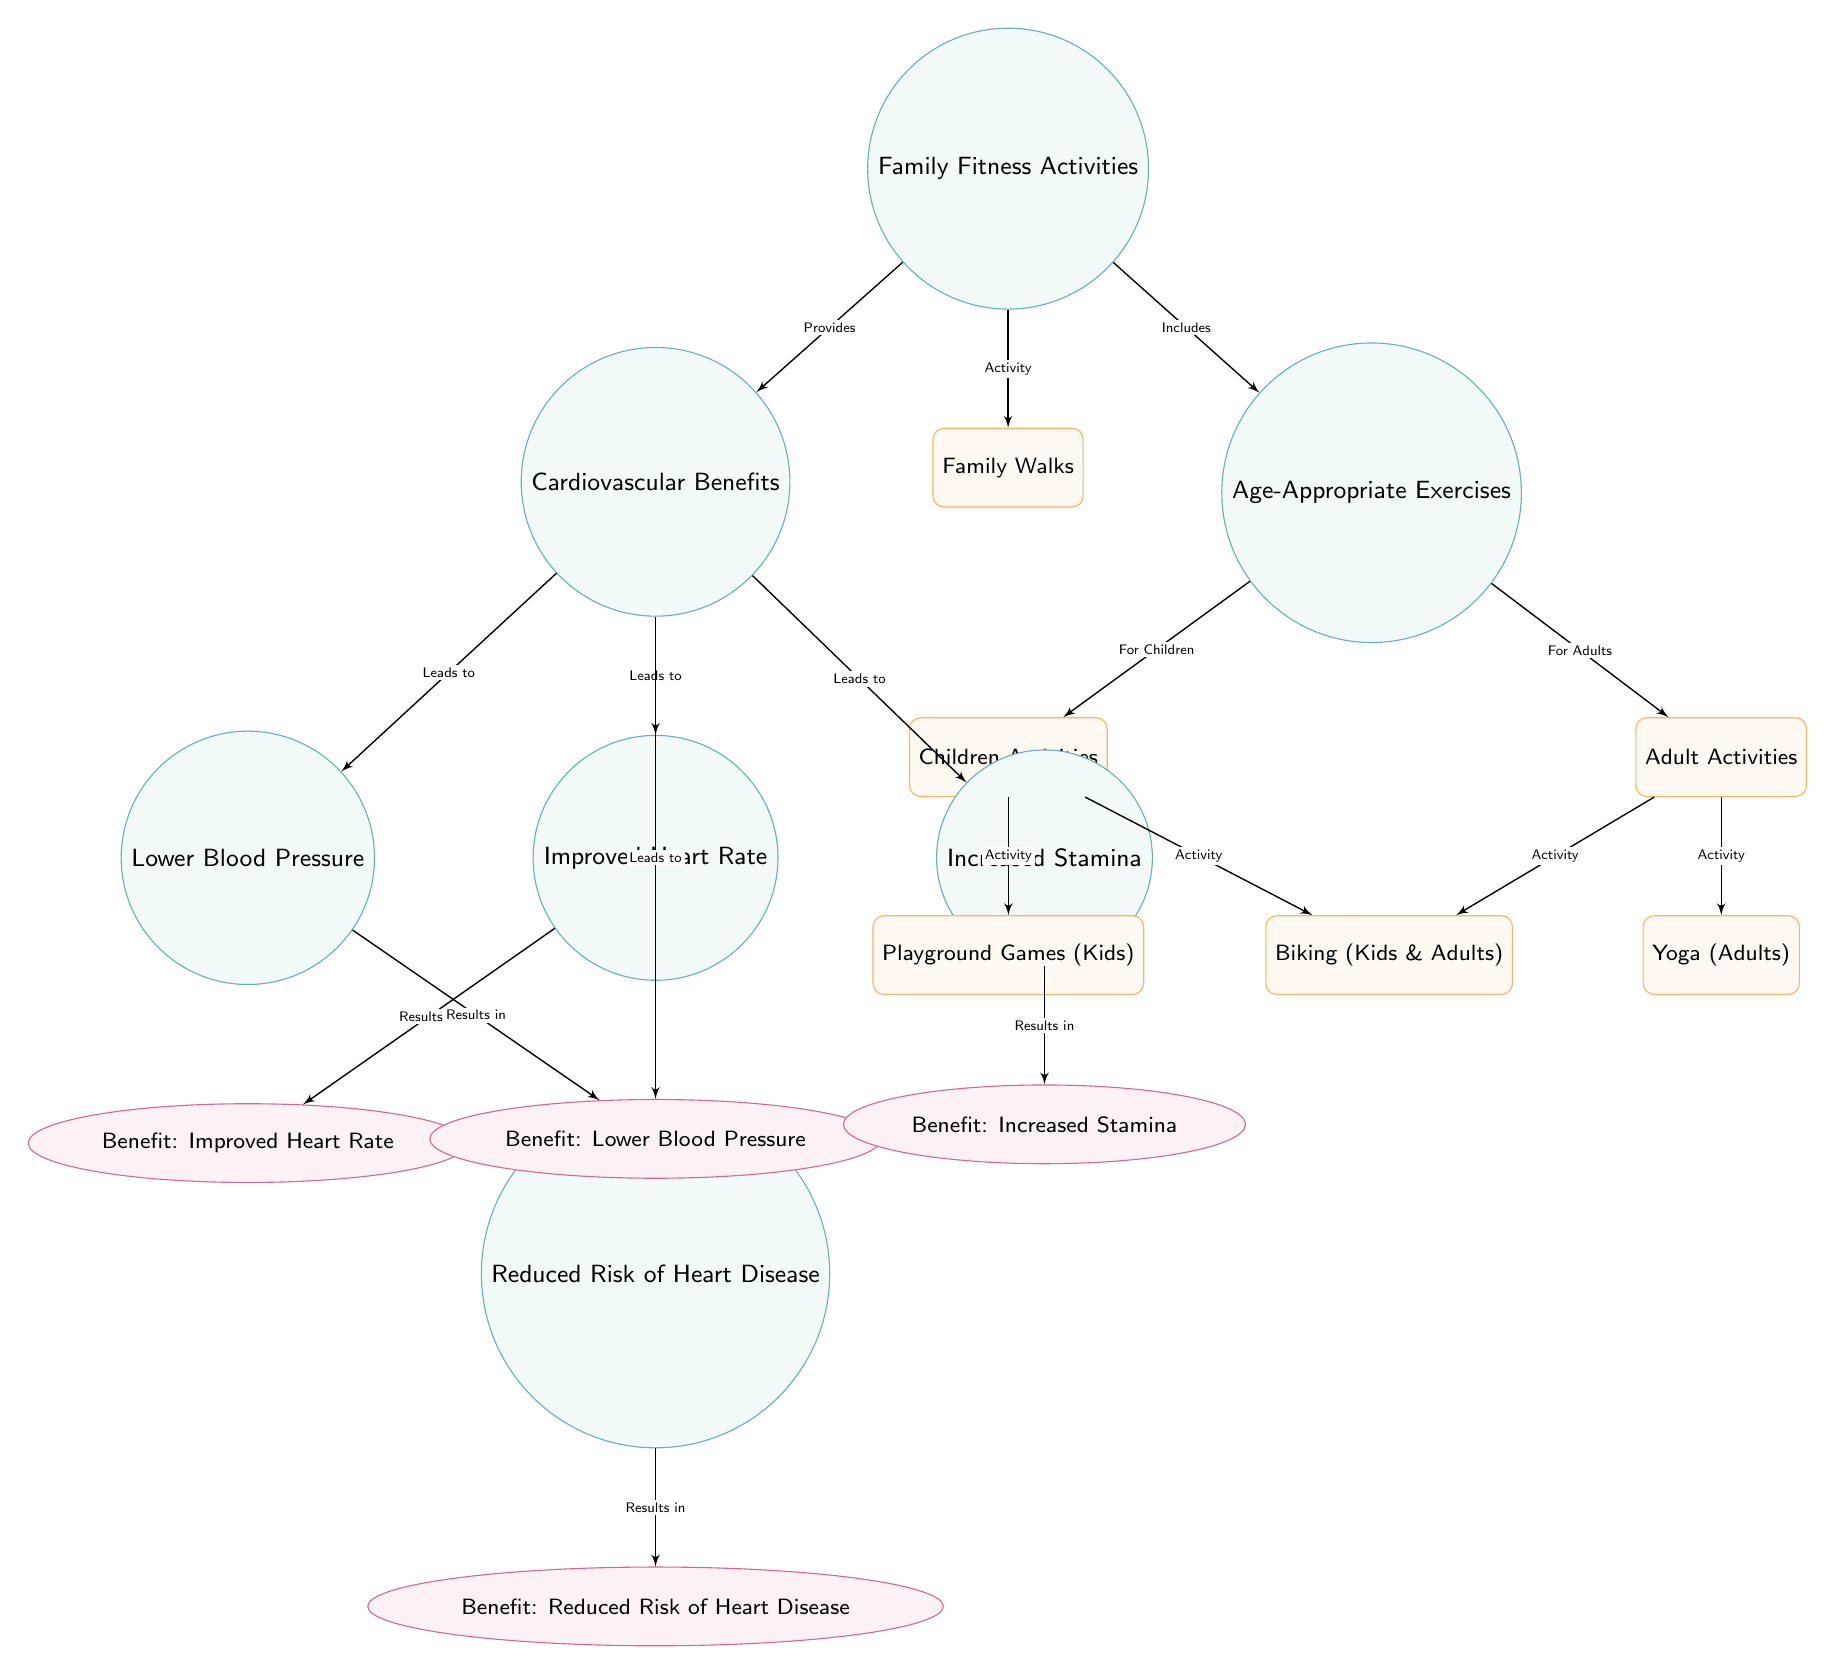What is the primary focus of this diagram? The diagram illustrates the connections between family fitness activities, their cardiovascular benefits, and age-appropriate exercises for children and adults. The central theme emphasizes how engaging in family fitness can improve heart health.
Answer: Family Fitness Activities How many cardiovascular benefits are listed in the diagram? The diagram identifies four specific cardiovascular benefits stemming from family fitness activities: improved heart rate, lower blood pressure, increased stamina, and reduced risk of heart disease. Counting these gives a total of four benefits.
Answer: 4 What exercise is listed for both children and adults? The diagram highlights "Biking" as an exercise that is appropriate for both children and adults, indicating its versatility as a family fitness activity.
Answer: Biking What is the age-appropriate exercise listed specifically for adults? "Yoga" is mentioned specifically as an age-appropriate exercise for adults, suggesting its importance for this age group in the context of family fitness activities.
Answer: Yoga What benefit is associated with improved heart rate? The benefit that results from improved heart rate is shown as "Benefit: Improved Heart Rate" in the diagram. This indicates a direct relationship between cardiovascular benefits and heart rate improvements.
Answer: Improved Heart Rate Which family fitness activity leads to reduced risk of heart disease? The diagram indicates that "Family Walks" is an activity included within family fitness activities that contribute to reduced risk of heart disease. This indicates its importance in cardiovascular health.
Answer: Family Walks Which age group does "Playground Games" target? The diagram specifies that "Playground Games" is targeted specifically at children, highlighting it as an age-appropriate exercise for that group.
Answer: Children What is the direct relationship between family fitness activities and cardiovascular benefits? The diagram illustrates that family fitness activities provide cardiovascular benefits, establishing a clear connection between participating in these activities and resulting health advantages.
Answer: Provides How does lower blood pressure relate to cardiovascular benefits? Lower blood pressure is shown as a direct outcome of engaging in cardiovascular benefits, indicating that involvement in physical activity can help regulate blood pressure levels.
Answer: Results in Lower Blood Pressure 